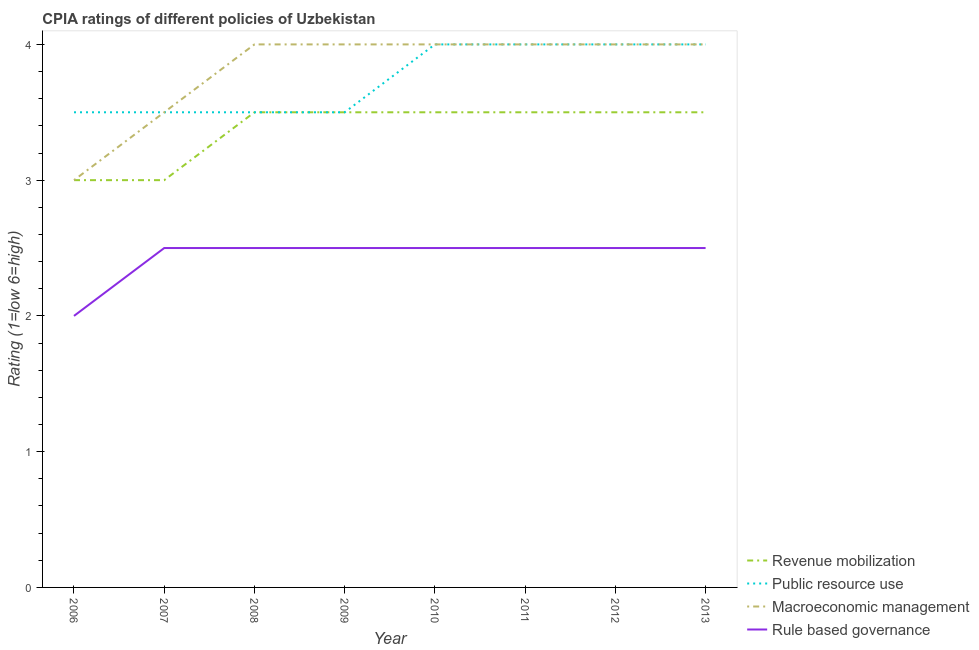How many different coloured lines are there?
Your answer should be very brief. 4. Does the line corresponding to cpia rating of macroeconomic management intersect with the line corresponding to cpia rating of rule based governance?
Ensure brevity in your answer.  No. Across all years, what is the maximum cpia rating of rule based governance?
Ensure brevity in your answer.  2.5. In which year was the cpia rating of revenue mobilization minimum?
Offer a terse response. 2006. What is the difference between the cpia rating of public resource use in 2009 and the cpia rating of rule based governance in 2006?
Give a very brief answer. 1.5. What is the average cpia rating of macroeconomic management per year?
Ensure brevity in your answer.  3.81. In how many years, is the cpia rating of rule based governance greater than 3.8?
Offer a terse response. 0. Is the difference between the cpia rating of public resource use in 2010 and 2011 greater than the difference between the cpia rating of macroeconomic management in 2010 and 2011?
Your answer should be very brief. No. What is the difference between the highest and the second highest cpia rating of rule based governance?
Provide a short and direct response. 0. In how many years, is the cpia rating of rule based governance greater than the average cpia rating of rule based governance taken over all years?
Offer a terse response. 7. Is the sum of the cpia rating of macroeconomic management in 2008 and 2011 greater than the maximum cpia rating of public resource use across all years?
Offer a very short reply. Yes. Is it the case that in every year, the sum of the cpia rating of public resource use and cpia rating of revenue mobilization is greater than the sum of cpia rating of rule based governance and cpia rating of macroeconomic management?
Offer a very short reply. No. Is it the case that in every year, the sum of the cpia rating of revenue mobilization and cpia rating of public resource use is greater than the cpia rating of macroeconomic management?
Offer a very short reply. Yes. Does the cpia rating of revenue mobilization monotonically increase over the years?
Ensure brevity in your answer.  No. How many lines are there?
Provide a succinct answer. 4. How many years are there in the graph?
Provide a succinct answer. 8. What is the difference between two consecutive major ticks on the Y-axis?
Provide a succinct answer. 1. Are the values on the major ticks of Y-axis written in scientific E-notation?
Provide a short and direct response. No. Does the graph contain any zero values?
Keep it short and to the point. No. Where does the legend appear in the graph?
Make the answer very short. Bottom right. How many legend labels are there?
Offer a terse response. 4. What is the title of the graph?
Provide a succinct answer. CPIA ratings of different policies of Uzbekistan. Does "United States" appear as one of the legend labels in the graph?
Give a very brief answer. No. What is the Rating (1=low 6=high) in Public resource use in 2006?
Your answer should be compact. 3.5. What is the Rating (1=low 6=high) in Rule based governance in 2006?
Make the answer very short. 2. What is the Rating (1=low 6=high) in Revenue mobilization in 2007?
Offer a very short reply. 3. What is the Rating (1=low 6=high) of Public resource use in 2007?
Your answer should be compact. 3.5. What is the Rating (1=low 6=high) in Macroeconomic management in 2007?
Your answer should be compact. 3.5. What is the Rating (1=low 6=high) of Revenue mobilization in 2008?
Provide a succinct answer. 3.5. What is the Rating (1=low 6=high) in Public resource use in 2008?
Offer a very short reply. 3.5. What is the Rating (1=low 6=high) in Macroeconomic management in 2008?
Your response must be concise. 4. What is the Rating (1=low 6=high) of Public resource use in 2009?
Ensure brevity in your answer.  3.5. What is the Rating (1=low 6=high) in Macroeconomic management in 2009?
Ensure brevity in your answer.  4. What is the Rating (1=low 6=high) in Revenue mobilization in 2010?
Your answer should be very brief. 3.5. What is the Rating (1=low 6=high) in Rule based governance in 2010?
Provide a short and direct response. 2.5. What is the Rating (1=low 6=high) in Macroeconomic management in 2011?
Your answer should be very brief. 4. What is the Rating (1=low 6=high) of Revenue mobilization in 2012?
Provide a short and direct response. 3.5. What is the Rating (1=low 6=high) in Macroeconomic management in 2012?
Ensure brevity in your answer.  4. What is the Rating (1=low 6=high) of Rule based governance in 2012?
Your response must be concise. 2.5. What is the Rating (1=low 6=high) in Public resource use in 2013?
Your answer should be compact. 4. What is the Rating (1=low 6=high) of Macroeconomic management in 2013?
Your answer should be very brief. 4. Across all years, what is the maximum Rating (1=low 6=high) in Revenue mobilization?
Keep it short and to the point. 3.5. Across all years, what is the maximum Rating (1=low 6=high) of Macroeconomic management?
Give a very brief answer. 4. What is the total Rating (1=low 6=high) of Revenue mobilization in the graph?
Ensure brevity in your answer.  27. What is the total Rating (1=low 6=high) of Public resource use in the graph?
Keep it short and to the point. 30. What is the total Rating (1=low 6=high) of Macroeconomic management in the graph?
Provide a short and direct response. 30.5. What is the total Rating (1=low 6=high) of Rule based governance in the graph?
Make the answer very short. 19.5. What is the difference between the Rating (1=low 6=high) in Public resource use in 2006 and that in 2008?
Keep it short and to the point. 0. What is the difference between the Rating (1=low 6=high) in Macroeconomic management in 2006 and that in 2008?
Offer a very short reply. -1. What is the difference between the Rating (1=low 6=high) in Rule based governance in 2006 and that in 2008?
Provide a short and direct response. -0.5. What is the difference between the Rating (1=low 6=high) in Public resource use in 2006 and that in 2009?
Your answer should be compact. 0. What is the difference between the Rating (1=low 6=high) of Macroeconomic management in 2006 and that in 2009?
Provide a succinct answer. -1. What is the difference between the Rating (1=low 6=high) of Macroeconomic management in 2006 and that in 2010?
Give a very brief answer. -1. What is the difference between the Rating (1=low 6=high) of Revenue mobilization in 2006 and that in 2011?
Make the answer very short. -0.5. What is the difference between the Rating (1=low 6=high) in Public resource use in 2006 and that in 2011?
Give a very brief answer. -0.5. What is the difference between the Rating (1=low 6=high) of Revenue mobilization in 2006 and that in 2012?
Your response must be concise. -0.5. What is the difference between the Rating (1=low 6=high) of Macroeconomic management in 2006 and that in 2012?
Offer a very short reply. -1. What is the difference between the Rating (1=low 6=high) in Revenue mobilization in 2006 and that in 2013?
Offer a very short reply. -0.5. What is the difference between the Rating (1=low 6=high) in Macroeconomic management in 2006 and that in 2013?
Ensure brevity in your answer.  -1. What is the difference between the Rating (1=low 6=high) of Rule based governance in 2006 and that in 2013?
Your answer should be compact. -0.5. What is the difference between the Rating (1=low 6=high) of Macroeconomic management in 2007 and that in 2009?
Offer a terse response. -0.5. What is the difference between the Rating (1=low 6=high) of Rule based governance in 2007 and that in 2010?
Ensure brevity in your answer.  0. What is the difference between the Rating (1=low 6=high) of Public resource use in 2007 and that in 2011?
Give a very brief answer. -0.5. What is the difference between the Rating (1=low 6=high) in Macroeconomic management in 2007 and that in 2011?
Ensure brevity in your answer.  -0.5. What is the difference between the Rating (1=low 6=high) of Rule based governance in 2007 and that in 2011?
Ensure brevity in your answer.  0. What is the difference between the Rating (1=low 6=high) of Public resource use in 2007 and that in 2012?
Keep it short and to the point. -0.5. What is the difference between the Rating (1=low 6=high) in Macroeconomic management in 2007 and that in 2012?
Offer a terse response. -0.5. What is the difference between the Rating (1=low 6=high) in Rule based governance in 2007 and that in 2012?
Your answer should be compact. 0. What is the difference between the Rating (1=low 6=high) of Revenue mobilization in 2007 and that in 2013?
Your response must be concise. -0.5. What is the difference between the Rating (1=low 6=high) in Macroeconomic management in 2007 and that in 2013?
Provide a succinct answer. -0.5. What is the difference between the Rating (1=low 6=high) of Revenue mobilization in 2008 and that in 2009?
Your response must be concise. 0. What is the difference between the Rating (1=low 6=high) of Macroeconomic management in 2008 and that in 2009?
Provide a succinct answer. 0. What is the difference between the Rating (1=low 6=high) of Rule based governance in 2008 and that in 2009?
Offer a terse response. 0. What is the difference between the Rating (1=low 6=high) in Revenue mobilization in 2008 and that in 2010?
Keep it short and to the point. 0. What is the difference between the Rating (1=low 6=high) of Macroeconomic management in 2008 and that in 2010?
Make the answer very short. 0. What is the difference between the Rating (1=low 6=high) of Revenue mobilization in 2008 and that in 2011?
Your answer should be very brief. 0. What is the difference between the Rating (1=low 6=high) of Rule based governance in 2008 and that in 2011?
Make the answer very short. 0. What is the difference between the Rating (1=low 6=high) in Revenue mobilization in 2008 and that in 2012?
Ensure brevity in your answer.  0. What is the difference between the Rating (1=low 6=high) of Macroeconomic management in 2008 and that in 2012?
Your response must be concise. 0. What is the difference between the Rating (1=low 6=high) of Rule based governance in 2008 and that in 2012?
Your response must be concise. 0. What is the difference between the Rating (1=low 6=high) of Revenue mobilization in 2008 and that in 2013?
Your answer should be very brief. 0. What is the difference between the Rating (1=low 6=high) in Public resource use in 2008 and that in 2013?
Provide a succinct answer. -0.5. What is the difference between the Rating (1=low 6=high) in Macroeconomic management in 2008 and that in 2013?
Give a very brief answer. 0. What is the difference between the Rating (1=low 6=high) in Revenue mobilization in 2009 and that in 2010?
Keep it short and to the point. 0. What is the difference between the Rating (1=low 6=high) in Macroeconomic management in 2009 and that in 2010?
Keep it short and to the point. 0. What is the difference between the Rating (1=low 6=high) of Public resource use in 2009 and that in 2011?
Provide a short and direct response. -0.5. What is the difference between the Rating (1=low 6=high) in Macroeconomic management in 2009 and that in 2011?
Your answer should be very brief. 0. What is the difference between the Rating (1=low 6=high) of Revenue mobilization in 2009 and that in 2012?
Provide a short and direct response. 0. What is the difference between the Rating (1=low 6=high) of Public resource use in 2009 and that in 2012?
Make the answer very short. -0.5. What is the difference between the Rating (1=low 6=high) of Public resource use in 2009 and that in 2013?
Ensure brevity in your answer.  -0.5. What is the difference between the Rating (1=low 6=high) in Macroeconomic management in 2009 and that in 2013?
Your answer should be compact. 0. What is the difference between the Rating (1=low 6=high) of Macroeconomic management in 2010 and that in 2011?
Keep it short and to the point. 0. What is the difference between the Rating (1=low 6=high) of Revenue mobilization in 2010 and that in 2012?
Provide a short and direct response. 0. What is the difference between the Rating (1=low 6=high) of Public resource use in 2010 and that in 2012?
Keep it short and to the point. 0. What is the difference between the Rating (1=low 6=high) in Rule based governance in 2010 and that in 2012?
Make the answer very short. 0. What is the difference between the Rating (1=low 6=high) in Revenue mobilization in 2010 and that in 2013?
Ensure brevity in your answer.  0. What is the difference between the Rating (1=low 6=high) of Macroeconomic management in 2010 and that in 2013?
Your answer should be very brief. 0. What is the difference between the Rating (1=low 6=high) in Macroeconomic management in 2011 and that in 2012?
Your answer should be compact. 0. What is the difference between the Rating (1=low 6=high) of Revenue mobilization in 2011 and that in 2013?
Your answer should be compact. 0. What is the difference between the Rating (1=low 6=high) in Macroeconomic management in 2011 and that in 2013?
Give a very brief answer. 0. What is the difference between the Rating (1=low 6=high) of Rule based governance in 2011 and that in 2013?
Keep it short and to the point. 0. What is the difference between the Rating (1=low 6=high) of Revenue mobilization in 2012 and that in 2013?
Provide a short and direct response. 0. What is the difference between the Rating (1=low 6=high) in Macroeconomic management in 2012 and that in 2013?
Your response must be concise. 0. What is the difference between the Rating (1=low 6=high) of Rule based governance in 2012 and that in 2013?
Your response must be concise. 0. What is the difference between the Rating (1=low 6=high) of Revenue mobilization in 2006 and the Rating (1=low 6=high) of Public resource use in 2007?
Make the answer very short. -0.5. What is the difference between the Rating (1=low 6=high) of Revenue mobilization in 2006 and the Rating (1=low 6=high) of Rule based governance in 2007?
Provide a short and direct response. 0.5. What is the difference between the Rating (1=low 6=high) of Public resource use in 2006 and the Rating (1=low 6=high) of Macroeconomic management in 2007?
Keep it short and to the point. 0. What is the difference between the Rating (1=low 6=high) in Public resource use in 2006 and the Rating (1=low 6=high) in Rule based governance in 2007?
Provide a succinct answer. 1. What is the difference between the Rating (1=low 6=high) of Macroeconomic management in 2006 and the Rating (1=low 6=high) of Rule based governance in 2007?
Keep it short and to the point. 0.5. What is the difference between the Rating (1=low 6=high) in Revenue mobilization in 2006 and the Rating (1=low 6=high) in Macroeconomic management in 2008?
Your answer should be very brief. -1. What is the difference between the Rating (1=low 6=high) of Revenue mobilization in 2006 and the Rating (1=low 6=high) of Rule based governance in 2008?
Provide a short and direct response. 0.5. What is the difference between the Rating (1=low 6=high) in Public resource use in 2006 and the Rating (1=low 6=high) in Macroeconomic management in 2008?
Make the answer very short. -0.5. What is the difference between the Rating (1=low 6=high) in Macroeconomic management in 2006 and the Rating (1=low 6=high) in Rule based governance in 2008?
Keep it short and to the point. 0.5. What is the difference between the Rating (1=low 6=high) in Revenue mobilization in 2006 and the Rating (1=low 6=high) in Macroeconomic management in 2009?
Your response must be concise. -1. What is the difference between the Rating (1=low 6=high) of Revenue mobilization in 2006 and the Rating (1=low 6=high) of Rule based governance in 2009?
Give a very brief answer. 0.5. What is the difference between the Rating (1=low 6=high) in Macroeconomic management in 2006 and the Rating (1=low 6=high) in Rule based governance in 2009?
Offer a very short reply. 0.5. What is the difference between the Rating (1=low 6=high) in Revenue mobilization in 2006 and the Rating (1=low 6=high) in Public resource use in 2010?
Your answer should be compact. -1. What is the difference between the Rating (1=low 6=high) of Revenue mobilization in 2006 and the Rating (1=low 6=high) of Macroeconomic management in 2010?
Ensure brevity in your answer.  -1. What is the difference between the Rating (1=low 6=high) in Macroeconomic management in 2006 and the Rating (1=low 6=high) in Rule based governance in 2010?
Offer a very short reply. 0.5. What is the difference between the Rating (1=low 6=high) in Revenue mobilization in 2006 and the Rating (1=low 6=high) in Macroeconomic management in 2011?
Provide a short and direct response. -1. What is the difference between the Rating (1=low 6=high) in Revenue mobilization in 2006 and the Rating (1=low 6=high) in Macroeconomic management in 2012?
Provide a short and direct response. -1. What is the difference between the Rating (1=low 6=high) of Public resource use in 2006 and the Rating (1=low 6=high) of Macroeconomic management in 2012?
Keep it short and to the point. -0.5. What is the difference between the Rating (1=low 6=high) in Public resource use in 2006 and the Rating (1=low 6=high) in Rule based governance in 2012?
Your answer should be compact. 1. What is the difference between the Rating (1=low 6=high) of Revenue mobilization in 2006 and the Rating (1=low 6=high) of Rule based governance in 2013?
Your response must be concise. 0.5. What is the difference between the Rating (1=low 6=high) in Public resource use in 2006 and the Rating (1=low 6=high) in Rule based governance in 2013?
Offer a very short reply. 1. What is the difference between the Rating (1=low 6=high) of Revenue mobilization in 2007 and the Rating (1=low 6=high) of Public resource use in 2008?
Ensure brevity in your answer.  -0.5. What is the difference between the Rating (1=low 6=high) of Revenue mobilization in 2007 and the Rating (1=low 6=high) of Macroeconomic management in 2008?
Provide a succinct answer. -1. What is the difference between the Rating (1=low 6=high) in Revenue mobilization in 2007 and the Rating (1=low 6=high) in Rule based governance in 2008?
Your answer should be compact. 0.5. What is the difference between the Rating (1=low 6=high) in Public resource use in 2007 and the Rating (1=low 6=high) in Macroeconomic management in 2008?
Your answer should be very brief. -0.5. What is the difference between the Rating (1=low 6=high) in Macroeconomic management in 2007 and the Rating (1=low 6=high) in Rule based governance in 2008?
Offer a terse response. 1. What is the difference between the Rating (1=low 6=high) in Revenue mobilization in 2007 and the Rating (1=low 6=high) in Public resource use in 2009?
Offer a very short reply. -0.5. What is the difference between the Rating (1=low 6=high) in Revenue mobilization in 2007 and the Rating (1=low 6=high) in Macroeconomic management in 2009?
Your response must be concise. -1. What is the difference between the Rating (1=low 6=high) of Revenue mobilization in 2007 and the Rating (1=low 6=high) of Rule based governance in 2009?
Provide a succinct answer. 0.5. What is the difference between the Rating (1=low 6=high) of Public resource use in 2007 and the Rating (1=low 6=high) of Macroeconomic management in 2009?
Provide a short and direct response. -0.5. What is the difference between the Rating (1=low 6=high) in Revenue mobilization in 2007 and the Rating (1=low 6=high) in Public resource use in 2010?
Provide a short and direct response. -1. What is the difference between the Rating (1=low 6=high) of Revenue mobilization in 2007 and the Rating (1=low 6=high) of Macroeconomic management in 2010?
Offer a terse response. -1. What is the difference between the Rating (1=low 6=high) of Public resource use in 2007 and the Rating (1=low 6=high) of Macroeconomic management in 2010?
Ensure brevity in your answer.  -0.5. What is the difference between the Rating (1=low 6=high) in Public resource use in 2007 and the Rating (1=low 6=high) in Rule based governance in 2010?
Provide a succinct answer. 1. What is the difference between the Rating (1=low 6=high) of Macroeconomic management in 2007 and the Rating (1=low 6=high) of Rule based governance in 2010?
Provide a succinct answer. 1. What is the difference between the Rating (1=low 6=high) in Revenue mobilization in 2007 and the Rating (1=low 6=high) in Public resource use in 2011?
Provide a short and direct response. -1. What is the difference between the Rating (1=low 6=high) of Revenue mobilization in 2007 and the Rating (1=low 6=high) of Rule based governance in 2011?
Provide a succinct answer. 0.5. What is the difference between the Rating (1=low 6=high) in Public resource use in 2007 and the Rating (1=low 6=high) in Macroeconomic management in 2011?
Your answer should be compact. -0.5. What is the difference between the Rating (1=low 6=high) of Macroeconomic management in 2007 and the Rating (1=low 6=high) of Rule based governance in 2011?
Provide a short and direct response. 1. What is the difference between the Rating (1=low 6=high) in Revenue mobilization in 2007 and the Rating (1=low 6=high) in Public resource use in 2012?
Your answer should be compact. -1. What is the difference between the Rating (1=low 6=high) in Revenue mobilization in 2007 and the Rating (1=low 6=high) in Macroeconomic management in 2012?
Offer a terse response. -1. What is the difference between the Rating (1=low 6=high) of Revenue mobilization in 2007 and the Rating (1=low 6=high) of Rule based governance in 2012?
Your answer should be very brief. 0.5. What is the difference between the Rating (1=low 6=high) of Public resource use in 2007 and the Rating (1=low 6=high) of Rule based governance in 2012?
Provide a succinct answer. 1. What is the difference between the Rating (1=low 6=high) in Revenue mobilization in 2007 and the Rating (1=low 6=high) in Macroeconomic management in 2013?
Your answer should be very brief. -1. What is the difference between the Rating (1=low 6=high) of Revenue mobilization in 2007 and the Rating (1=low 6=high) of Rule based governance in 2013?
Offer a very short reply. 0.5. What is the difference between the Rating (1=low 6=high) of Public resource use in 2007 and the Rating (1=low 6=high) of Macroeconomic management in 2013?
Make the answer very short. -0.5. What is the difference between the Rating (1=low 6=high) in Macroeconomic management in 2007 and the Rating (1=low 6=high) in Rule based governance in 2013?
Give a very brief answer. 1. What is the difference between the Rating (1=low 6=high) of Revenue mobilization in 2008 and the Rating (1=low 6=high) of Public resource use in 2009?
Ensure brevity in your answer.  0. What is the difference between the Rating (1=low 6=high) in Revenue mobilization in 2008 and the Rating (1=low 6=high) in Rule based governance in 2009?
Keep it short and to the point. 1. What is the difference between the Rating (1=low 6=high) of Public resource use in 2008 and the Rating (1=low 6=high) of Rule based governance in 2009?
Your answer should be compact. 1. What is the difference between the Rating (1=low 6=high) of Macroeconomic management in 2008 and the Rating (1=low 6=high) of Rule based governance in 2009?
Give a very brief answer. 1.5. What is the difference between the Rating (1=low 6=high) in Revenue mobilization in 2008 and the Rating (1=low 6=high) in Public resource use in 2010?
Provide a short and direct response. -0.5. What is the difference between the Rating (1=low 6=high) of Revenue mobilization in 2008 and the Rating (1=low 6=high) of Macroeconomic management in 2010?
Provide a short and direct response. -0.5. What is the difference between the Rating (1=low 6=high) of Revenue mobilization in 2008 and the Rating (1=low 6=high) of Rule based governance in 2010?
Ensure brevity in your answer.  1. What is the difference between the Rating (1=low 6=high) of Public resource use in 2008 and the Rating (1=low 6=high) of Macroeconomic management in 2010?
Offer a very short reply. -0.5. What is the difference between the Rating (1=low 6=high) of Public resource use in 2008 and the Rating (1=low 6=high) of Rule based governance in 2010?
Your answer should be compact. 1. What is the difference between the Rating (1=low 6=high) of Revenue mobilization in 2008 and the Rating (1=low 6=high) of Macroeconomic management in 2011?
Your answer should be very brief. -0.5. What is the difference between the Rating (1=low 6=high) in Public resource use in 2008 and the Rating (1=low 6=high) in Rule based governance in 2011?
Provide a short and direct response. 1. What is the difference between the Rating (1=low 6=high) of Macroeconomic management in 2008 and the Rating (1=low 6=high) of Rule based governance in 2011?
Offer a terse response. 1.5. What is the difference between the Rating (1=low 6=high) in Revenue mobilization in 2008 and the Rating (1=low 6=high) in Macroeconomic management in 2012?
Provide a short and direct response. -0.5. What is the difference between the Rating (1=low 6=high) of Public resource use in 2008 and the Rating (1=low 6=high) of Macroeconomic management in 2012?
Keep it short and to the point. -0.5. What is the difference between the Rating (1=low 6=high) of Public resource use in 2008 and the Rating (1=low 6=high) of Rule based governance in 2012?
Your answer should be very brief. 1. What is the difference between the Rating (1=low 6=high) of Public resource use in 2008 and the Rating (1=low 6=high) of Rule based governance in 2013?
Ensure brevity in your answer.  1. What is the difference between the Rating (1=low 6=high) of Macroeconomic management in 2008 and the Rating (1=low 6=high) of Rule based governance in 2013?
Provide a short and direct response. 1.5. What is the difference between the Rating (1=low 6=high) in Revenue mobilization in 2009 and the Rating (1=low 6=high) in Macroeconomic management in 2010?
Your response must be concise. -0.5. What is the difference between the Rating (1=low 6=high) in Public resource use in 2009 and the Rating (1=low 6=high) in Macroeconomic management in 2011?
Your answer should be compact. -0.5. What is the difference between the Rating (1=low 6=high) of Public resource use in 2009 and the Rating (1=low 6=high) of Rule based governance in 2011?
Offer a terse response. 1. What is the difference between the Rating (1=low 6=high) in Macroeconomic management in 2009 and the Rating (1=low 6=high) in Rule based governance in 2011?
Make the answer very short. 1.5. What is the difference between the Rating (1=low 6=high) in Revenue mobilization in 2009 and the Rating (1=low 6=high) in Macroeconomic management in 2012?
Provide a succinct answer. -0.5. What is the difference between the Rating (1=low 6=high) in Revenue mobilization in 2009 and the Rating (1=low 6=high) in Rule based governance in 2012?
Make the answer very short. 1. What is the difference between the Rating (1=low 6=high) in Macroeconomic management in 2009 and the Rating (1=low 6=high) in Rule based governance in 2012?
Keep it short and to the point. 1.5. What is the difference between the Rating (1=low 6=high) in Revenue mobilization in 2009 and the Rating (1=low 6=high) in Public resource use in 2013?
Offer a very short reply. -0.5. What is the difference between the Rating (1=low 6=high) of Revenue mobilization in 2009 and the Rating (1=low 6=high) of Macroeconomic management in 2013?
Provide a succinct answer. -0.5. What is the difference between the Rating (1=low 6=high) of Revenue mobilization in 2009 and the Rating (1=low 6=high) of Rule based governance in 2013?
Make the answer very short. 1. What is the difference between the Rating (1=low 6=high) of Public resource use in 2009 and the Rating (1=low 6=high) of Macroeconomic management in 2013?
Make the answer very short. -0.5. What is the difference between the Rating (1=low 6=high) in Macroeconomic management in 2009 and the Rating (1=low 6=high) in Rule based governance in 2013?
Provide a succinct answer. 1.5. What is the difference between the Rating (1=low 6=high) in Revenue mobilization in 2010 and the Rating (1=low 6=high) in Macroeconomic management in 2011?
Provide a succinct answer. -0.5. What is the difference between the Rating (1=low 6=high) in Macroeconomic management in 2010 and the Rating (1=low 6=high) in Rule based governance in 2011?
Provide a short and direct response. 1.5. What is the difference between the Rating (1=low 6=high) in Revenue mobilization in 2010 and the Rating (1=low 6=high) in Macroeconomic management in 2012?
Provide a succinct answer. -0.5. What is the difference between the Rating (1=low 6=high) of Public resource use in 2010 and the Rating (1=low 6=high) of Rule based governance in 2012?
Provide a short and direct response. 1.5. What is the difference between the Rating (1=low 6=high) in Macroeconomic management in 2010 and the Rating (1=low 6=high) in Rule based governance in 2012?
Ensure brevity in your answer.  1.5. What is the difference between the Rating (1=low 6=high) of Revenue mobilization in 2010 and the Rating (1=low 6=high) of Public resource use in 2013?
Give a very brief answer. -0.5. What is the difference between the Rating (1=low 6=high) in Revenue mobilization in 2010 and the Rating (1=low 6=high) in Macroeconomic management in 2013?
Keep it short and to the point. -0.5. What is the difference between the Rating (1=low 6=high) in Public resource use in 2010 and the Rating (1=low 6=high) in Macroeconomic management in 2013?
Offer a very short reply. 0. What is the difference between the Rating (1=low 6=high) in Macroeconomic management in 2010 and the Rating (1=low 6=high) in Rule based governance in 2013?
Your answer should be compact. 1.5. What is the difference between the Rating (1=low 6=high) of Revenue mobilization in 2011 and the Rating (1=low 6=high) of Public resource use in 2012?
Provide a succinct answer. -0.5. What is the difference between the Rating (1=low 6=high) in Revenue mobilization in 2011 and the Rating (1=low 6=high) in Macroeconomic management in 2012?
Offer a very short reply. -0.5. What is the difference between the Rating (1=low 6=high) of Public resource use in 2011 and the Rating (1=low 6=high) of Macroeconomic management in 2012?
Provide a short and direct response. 0. What is the difference between the Rating (1=low 6=high) of Public resource use in 2011 and the Rating (1=low 6=high) of Rule based governance in 2012?
Make the answer very short. 1.5. What is the difference between the Rating (1=low 6=high) in Macroeconomic management in 2011 and the Rating (1=low 6=high) in Rule based governance in 2012?
Your answer should be very brief. 1.5. What is the difference between the Rating (1=low 6=high) of Revenue mobilization in 2011 and the Rating (1=low 6=high) of Macroeconomic management in 2013?
Make the answer very short. -0.5. What is the difference between the Rating (1=low 6=high) in Revenue mobilization in 2011 and the Rating (1=low 6=high) in Rule based governance in 2013?
Your answer should be very brief. 1. What is the difference between the Rating (1=low 6=high) in Public resource use in 2011 and the Rating (1=low 6=high) in Rule based governance in 2013?
Provide a succinct answer. 1.5. What is the difference between the Rating (1=low 6=high) of Revenue mobilization in 2012 and the Rating (1=low 6=high) of Rule based governance in 2013?
Your response must be concise. 1. What is the difference between the Rating (1=low 6=high) in Public resource use in 2012 and the Rating (1=low 6=high) in Macroeconomic management in 2013?
Give a very brief answer. 0. What is the average Rating (1=low 6=high) of Revenue mobilization per year?
Keep it short and to the point. 3.38. What is the average Rating (1=low 6=high) of Public resource use per year?
Provide a succinct answer. 3.75. What is the average Rating (1=low 6=high) in Macroeconomic management per year?
Your answer should be very brief. 3.81. What is the average Rating (1=low 6=high) of Rule based governance per year?
Offer a very short reply. 2.44. In the year 2006, what is the difference between the Rating (1=low 6=high) of Public resource use and Rating (1=low 6=high) of Rule based governance?
Provide a succinct answer. 1.5. In the year 2007, what is the difference between the Rating (1=low 6=high) of Revenue mobilization and Rating (1=low 6=high) of Public resource use?
Offer a very short reply. -0.5. In the year 2007, what is the difference between the Rating (1=low 6=high) in Revenue mobilization and Rating (1=low 6=high) in Rule based governance?
Give a very brief answer. 0.5. In the year 2007, what is the difference between the Rating (1=low 6=high) in Public resource use and Rating (1=low 6=high) in Rule based governance?
Offer a terse response. 1. In the year 2007, what is the difference between the Rating (1=low 6=high) in Macroeconomic management and Rating (1=low 6=high) in Rule based governance?
Make the answer very short. 1. In the year 2008, what is the difference between the Rating (1=low 6=high) of Revenue mobilization and Rating (1=low 6=high) of Public resource use?
Your answer should be compact. 0. In the year 2008, what is the difference between the Rating (1=low 6=high) in Public resource use and Rating (1=low 6=high) in Macroeconomic management?
Ensure brevity in your answer.  -0.5. In the year 2009, what is the difference between the Rating (1=low 6=high) in Revenue mobilization and Rating (1=low 6=high) in Public resource use?
Offer a very short reply. 0. In the year 2009, what is the difference between the Rating (1=low 6=high) in Revenue mobilization and Rating (1=low 6=high) in Macroeconomic management?
Make the answer very short. -0.5. In the year 2009, what is the difference between the Rating (1=low 6=high) in Public resource use and Rating (1=low 6=high) in Macroeconomic management?
Your answer should be very brief. -0.5. In the year 2009, what is the difference between the Rating (1=low 6=high) of Public resource use and Rating (1=low 6=high) of Rule based governance?
Make the answer very short. 1. In the year 2009, what is the difference between the Rating (1=low 6=high) of Macroeconomic management and Rating (1=low 6=high) of Rule based governance?
Your answer should be compact. 1.5. In the year 2010, what is the difference between the Rating (1=low 6=high) of Revenue mobilization and Rating (1=low 6=high) of Rule based governance?
Your response must be concise. 1. In the year 2010, what is the difference between the Rating (1=low 6=high) in Public resource use and Rating (1=low 6=high) in Macroeconomic management?
Your answer should be very brief. 0. In the year 2010, what is the difference between the Rating (1=low 6=high) in Public resource use and Rating (1=low 6=high) in Rule based governance?
Your answer should be very brief. 1.5. In the year 2011, what is the difference between the Rating (1=low 6=high) in Revenue mobilization and Rating (1=low 6=high) in Macroeconomic management?
Give a very brief answer. -0.5. In the year 2011, what is the difference between the Rating (1=low 6=high) of Revenue mobilization and Rating (1=low 6=high) of Rule based governance?
Your response must be concise. 1. In the year 2011, what is the difference between the Rating (1=low 6=high) of Public resource use and Rating (1=low 6=high) of Macroeconomic management?
Keep it short and to the point. 0. In the year 2011, what is the difference between the Rating (1=low 6=high) of Public resource use and Rating (1=low 6=high) of Rule based governance?
Ensure brevity in your answer.  1.5. In the year 2011, what is the difference between the Rating (1=low 6=high) of Macroeconomic management and Rating (1=low 6=high) of Rule based governance?
Your answer should be very brief. 1.5. In the year 2012, what is the difference between the Rating (1=low 6=high) of Revenue mobilization and Rating (1=low 6=high) of Public resource use?
Keep it short and to the point. -0.5. In the year 2012, what is the difference between the Rating (1=low 6=high) of Public resource use and Rating (1=low 6=high) of Rule based governance?
Your answer should be very brief. 1.5. In the year 2012, what is the difference between the Rating (1=low 6=high) of Macroeconomic management and Rating (1=low 6=high) of Rule based governance?
Ensure brevity in your answer.  1.5. In the year 2013, what is the difference between the Rating (1=low 6=high) of Revenue mobilization and Rating (1=low 6=high) of Public resource use?
Offer a very short reply. -0.5. In the year 2013, what is the difference between the Rating (1=low 6=high) in Revenue mobilization and Rating (1=low 6=high) in Rule based governance?
Provide a short and direct response. 1. In the year 2013, what is the difference between the Rating (1=low 6=high) of Public resource use and Rating (1=low 6=high) of Rule based governance?
Your answer should be compact. 1.5. What is the ratio of the Rating (1=low 6=high) in Public resource use in 2006 to that in 2007?
Give a very brief answer. 1. What is the ratio of the Rating (1=low 6=high) of Rule based governance in 2006 to that in 2007?
Your response must be concise. 0.8. What is the ratio of the Rating (1=low 6=high) in Revenue mobilization in 2006 to that in 2008?
Offer a terse response. 0.86. What is the ratio of the Rating (1=low 6=high) of Public resource use in 2006 to that in 2008?
Your response must be concise. 1. What is the ratio of the Rating (1=low 6=high) of Macroeconomic management in 2006 to that in 2008?
Your answer should be very brief. 0.75. What is the ratio of the Rating (1=low 6=high) in Revenue mobilization in 2006 to that in 2009?
Give a very brief answer. 0.86. What is the ratio of the Rating (1=low 6=high) in Macroeconomic management in 2006 to that in 2009?
Give a very brief answer. 0.75. What is the ratio of the Rating (1=low 6=high) of Rule based governance in 2006 to that in 2009?
Your answer should be very brief. 0.8. What is the ratio of the Rating (1=low 6=high) in Macroeconomic management in 2006 to that in 2010?
Provide a short and direct response. 0.75. What is the ratio of the Rating (1=low 6=high) of Rule based governance in 2006 to that in 2011?
Your response must be concise. 0.8. What is the ratio of the Rating (1=low 6=high) of Rule based governance in 2006 to that in 2012?
Your answer should be very brief. 0.8. What is the ratio of the Rating (1=low 6=high) of Rule based governance in 2006 to that in 2013?
Offer a very short reply. 0.8. What is the ratio of the Rating (1=low 6=high) of Macroeconomic management in 2007 to that in 2008?
Provide a short and direct response. 0.88. What is the ratio of the Rating (1=low 6=high) in Rule based governance in 2007 to that in 2008?
Give a very brief answer. 1. What is the ratio of the Rating (1=low 6=high) of Revenue mobilization in 2007 to that in 2009?
Your answer should be compact. 0.86. What is the ratio of the Rating (1=low 6=high) of Public resource use in 2007 to that in 2009?
Provide a succinct answer. 1. What is the ratio of the Rating (1=low 6=high) in Rule based governance in 2007 to that in 2009?
Give a very brief answer. 1. What is the ratio of the Rating (1=low 6=high) in Rule based governance in 2007 to that in 2010?
Your response must be concise. 1. What is the ratio of the Rating (1=low 6=high) of Public resource use in 2007 to that in 2011?
Provide a short and direct response. 0.88. What is the ratio of the Rating (1=low 6=high) in Revenue mobilization in 2007 to that in 2012?
Ensure brevity in your answer.  0.86. What is the ratio of the Rating (1=low 6=high) of Revenue mobilization in 2007 to that in 2013?
Make the answer very short. 0.86. What is the ratio of the Rating (1=low 6=high) of Macroeconomic management in 2007 to that in 2013?
Your answer should be compact. 0.88. What is the ratio of the Rating (1=low 6=high) of Rule based governance in 2007 to that in 2013?
Offer a very short reply. 1. What is the ratio of the Rating (1=low 6=high) of Macroeconomic management in 2008 to that in 2010?
Your response must be concise. 1. What is the ratio of the Rating (1=low 6=high) of Revenue mobilization in 2008 to that in 2011?
Provide a short and direct response. 1. What is the ratio of the Rating (1=low 6=high) of Public resource use in 2008 to that in 2011?
Provide a short and direct response. 0.88. What is the ratio of the Rating (1=low 6=high) of Macroeconomic management in 2008 to that in 2011?
Provide a succinct answer. 1. What is the ratio of the Rating (1=low 6=high) in Revenue mobilization in 2008 to that in 2012?
Your answer should be compact. 1. What is the ratio of the Rating (1=low 6=high) in Public resource use in 2008 to that in 2012?
Offer a terse response. 0.88. What is the ratio of the Rating (1=low 6=high) in Public resource use in 2008 to that in 2013?
Make the answer very short. 0.88. What is the ratio of the Rating (1=low 6=high) of Revenue mobilization in 2009 to that in 2010?
Your response must be concise. 1. What is the ratio of the Rating (1=low 6=high) of Rule based governance in 2009 to that in 2010?
Offer a terse response. 1. What is the ratio of the Rating (1=low 6=high) in Revenue mobilization in 2009 to that in 2011?
Make the answer very short. 1. What is the ratio of the Rating (1=low 6=high) in Public resource use in 2009 to that in 2011?
Provide a succinct answer. 0.88. What is the ratio of the Rating (1=low 6=high) of Public resource use in 2009 to that in 2012?
Keep it short and to the point. 0.88. What is the ratio of the Rating (1=low 6=high) in Revenue mobilization in 2009 to that in 2013?
Offer a very short reply. 1. What is the ratio of the Rating (1=low 6=high) of Macroeconomic management in 2009 to that in 2013?
Your answer should be compact. 1. What is the ratio of the Rating (1=low 6=high) of Rule based governance in 2009 to that in 2013?
Your answer should be compact. 1. What is the ratio of the Rating (1=low 6=high) of Rule based governance in 2010 to that in 2011?
Provide a succinct answer. 1. What is the ratio of the Rating (1=low 6=high) of Revenue mobilization in 2010 to that in 2012?
Your answer should be very brief. 1. What is the ratio of the Rating (1=low 6=high) of Macroeconomic management in 2010 to that in 2012?
Offer a terse response. 1. What is the ratio of the Rating (1=low 6=high) of Revenue mobilization in 2010 to that in 2013?
Offer a very short reply. 1. What is the ratio of the Rating (1=low 6=high) of Macroeconomic management in 2010 to that in 2013?
Ensure brevity in your answer.  1. What is the ratio of the Rating (1=low 6=high) in Revenue mobilization in 2011 to that in 2013?
Your response must be concise. 1. What is the ratio of the Rating (1=low 6=high) in Public resource use in 2011 to that in 2013?
Offer a terse response. 1. What is the ratio of the Rating (1=low 6=high) of Revenue mobilization in 2012 to that in 2013?
Make the answer very short. 1. What is the ratio of the Rating (1=low 6=high) in Macroeconomic management in 2012 to that in 2013?
Offer a very short reply. 1. What is the difference between the highest and the second highest Rating (1=low 6=high) of Public resource use?
Your response must be concise. 0. What is the difference between the highest and the lowest Rating (1=low 6=high) of Revenue mobilization?
Your answer should be very brief. 0.5. What is the difference between the highest and the lowest Rating (1=low 6=high) of Public resource use?
Your answer should be very brief. 0.5. What is the difference between the highest and the lowest Rating (1=low 6=high) in Macroeconomic management?
Your response must be concise. 1. 